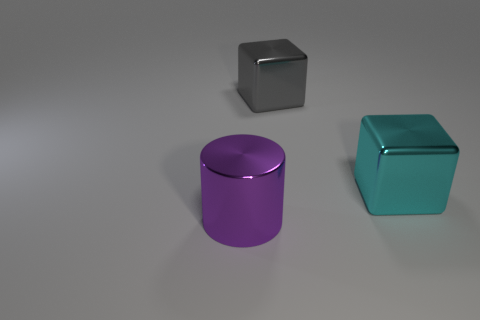Add 1 tiny red rubber blocks. How many objects exist? 4 Subtract 0 red cubes. How many objects are left? 3 Subtract all cubes. How many objects are left? 1 Subtract all big rubber balls. Subtract all metallic things. How many objects are left? 0 Add 2 large shiny cylinders. How many large shiny cylinders are left? 3 Add 2 tiny shiny cubes. How many tiny shiny cubes exist? 2 